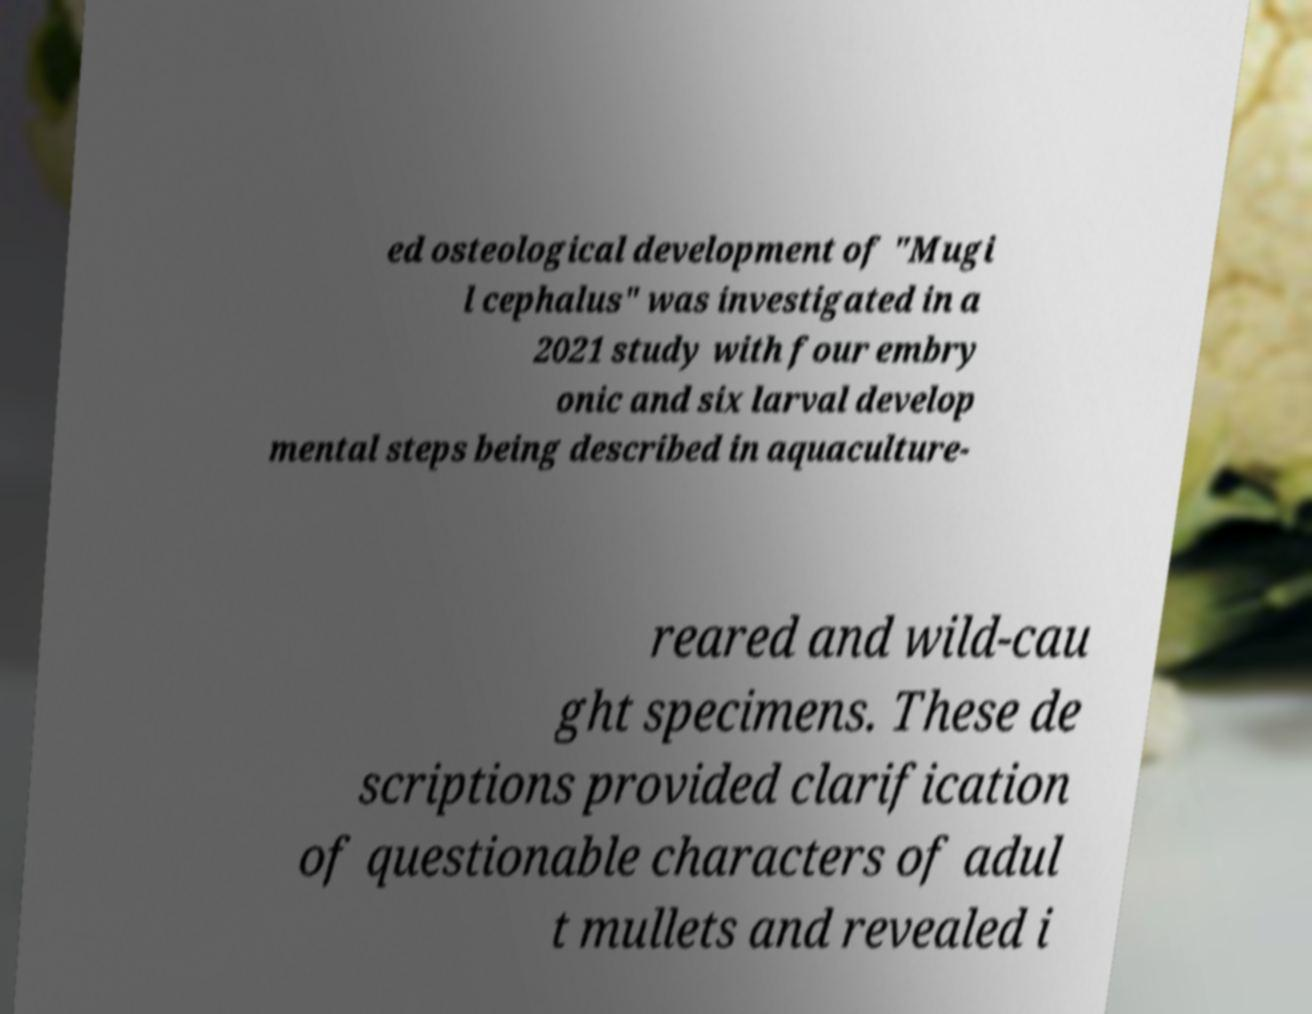For documentation purposes, I need the text within this image transcribed. Could you provide that? ed osteological development of "Mugi l cephalus" was investigated in a 2021 study with four embry onic and six larval develop mental steps being described in aquaculture- reared and wild-cau ght specimens. These de scriptions provided clarification of questionable characters of adul t mullets and revealed i 